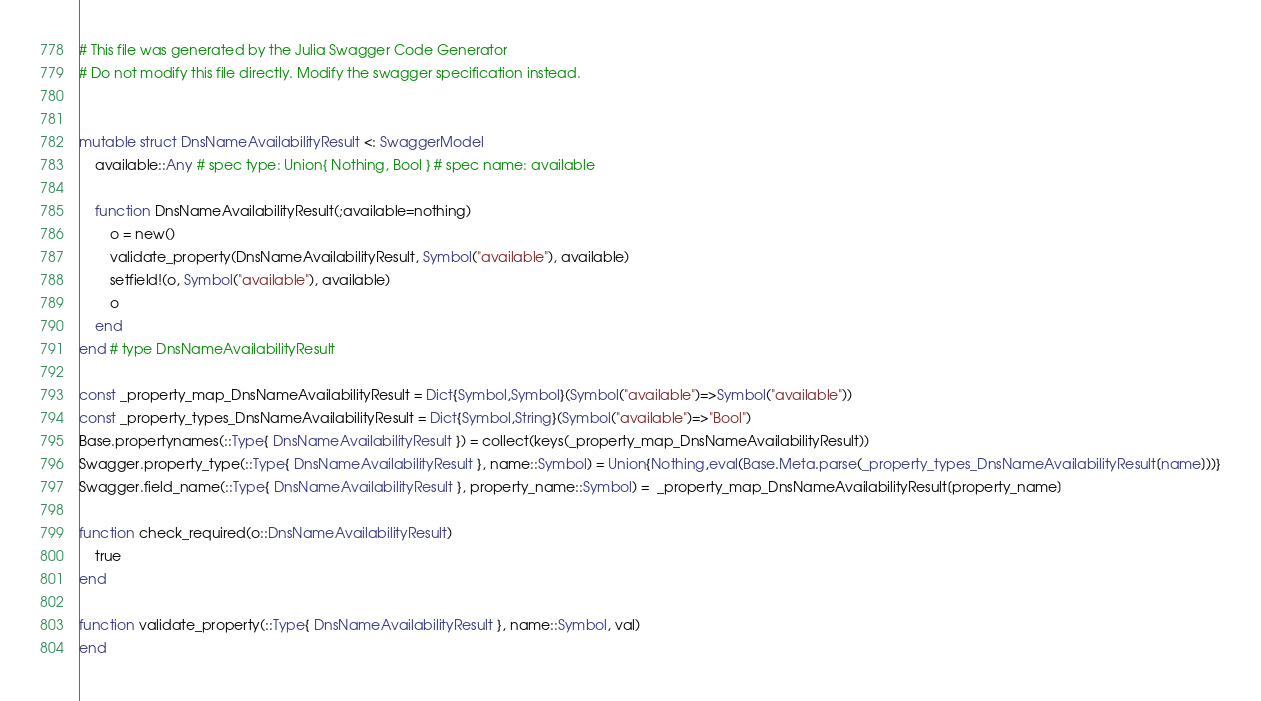Convert code to text. <code><loc_0><loc_0><loc_500><loc_500><_Julia_># This file was generated by the Julia Swagger Code Generator
# Do not modify this file directly. Modify the swagger specification instead.


mutable struct DnsNameAvailabilityResult <: SwaggerModel
    available::Any # spec type: Union{ Nothing, Bool } # spec name: available

    function DnsNameAvailabilityResult(;available=nothing)
        o = new()
        validate_property(DnsNameAvailabilityResult, Symbol("available"), available)
        setfield!(o, Symbol("available"), available)
        o
    end
end # type DnsNameAvailabilityResult

const _property_map_DnsNameAvailabilityResult = Dict{Symbol,Symbol}(Symbol("available")=>Symbol("available"))
const _property_types_DnsNameAvailabilityResult = Dict{Symbol,String}(Symbol("available")=>"Bool")
Base.propertynames(::Type{ DnsNameAvailabilityResult }) = collect(keys(_property_map_DnsNameAvailabilityResult))
Swagger.property_type(::Type{ DnsNameAvailabilityResult }, name::Symbol) = Union{Nothing,eval(Base.Meta.parse(_property_types_DnsNameAvailabilityResult[name]))}
Swagger.field_name(::Type{ DnsNameAvailabilityResult }, property_name::Symbol) =  _property_map_DnsNameAvailabilityResult[property_name]

function check_required(o::DnsNameAvailabilityResult)
    true
end

function validate_property(::Type{ DnsNameAvailabilityResult }, name::Symbol, val)
end
</code> 